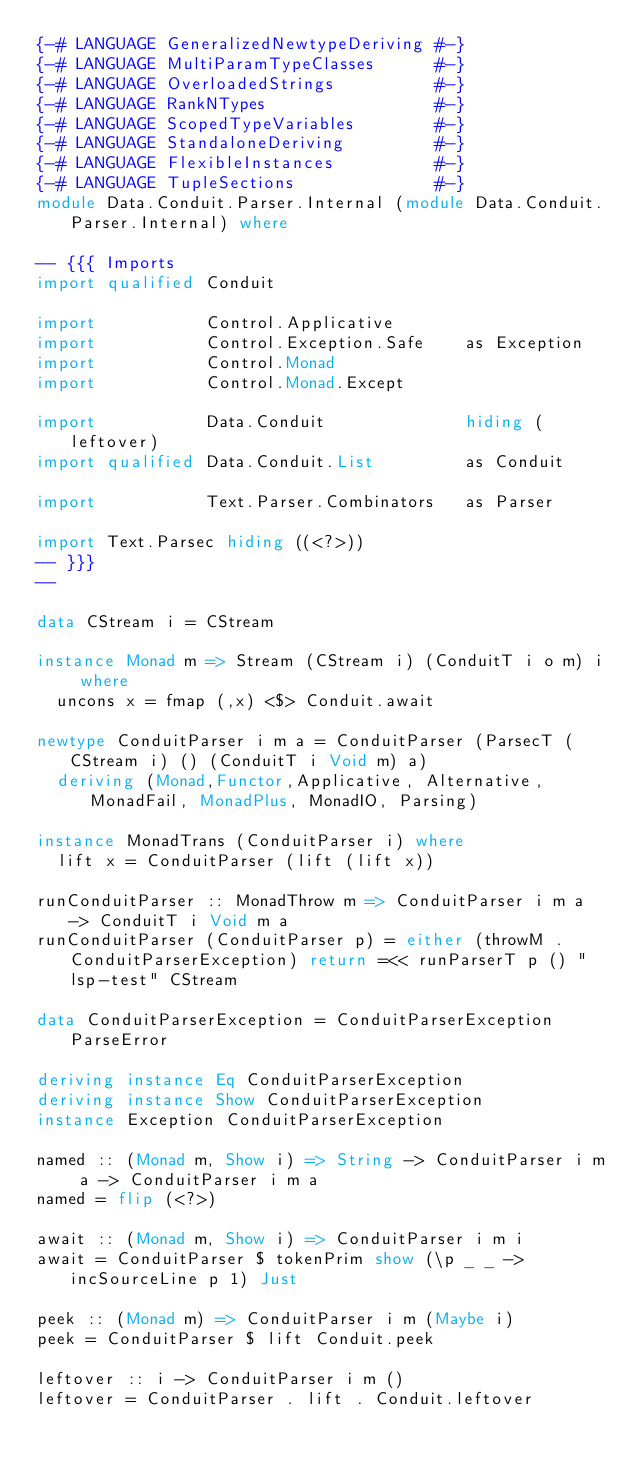<code> <loc_0><loc_0><loc_500><loc_500><_Haskell_>{-# LANGUAGE GeneralizedNewtypeDeriving #-}
{-# LANGUAGE MultiParamTypeClasses      #-}
{-# LANGUAGE OverloadedStrings          #-}
{-# LANGUAGE RankNTypes                 #-}
{-# LANGUAGE ScopedTypeVariables        #-}
{-# LANGUAGE StandaloneDeriving         #-}
{-# LANGUAGE FlexibleInstances          #-}
{-# LANGUAGE TupleSections              #-}
module Data.Conduit.Parser.Internal (module Data.Conduit.Parser.Internal) where

-- {{{ Imports
import qualified Conduit

import           Control.Applicative
import           Control.Exception.Safe    as Exception
import           Control.Monad
import           Control.Monad.Except

import           Data.Conduit              hiding (leftover)
import qualified Data.Conduit.List         as Conduit

import           Text.Parser.Combinators   as Parser

import Text.Parsec hiding ((<?>))
-- }}}
--

data CStream i = CStream

instance Monad m => Stream (CStream i) (ConduitT i o m) i where
  uncons x = fmap (,x) <$> Conduit.await

newtype ConduitParser i m a = ConduitParser (ParsecT (CStream i) () (ConduitT i Void m) a)
  deriving (Monad,Functor,Applicative, Alternative,MonadFail, MonadPlus, MonadIO, Parsing)

instance MonadTrans (ConduitParser i) where
  lift x = ConduitParser (lift (lift x))

runConduitParser :: MonadThrow m => ConduitParser i m a -> ConduitT i Void m a
runConduitParser (ConduitParser p) = either (throwM . ConduitParserException) return =<< runParserT p () "lsp-test" CStream

data ConduitParserException = ConduitParserException ParseError

deriving instance Eq ConduitParserException
deriving instance Show ConduitParserException
instance Exception ConduitParserException

named :: (Monad m, Show i) => String -> ConduitParser i m a -> ConduitParser i m a
named = flip (<?>)

await :: (Monad m, Show i) => ConduitParser i m i
await = ConduitParser $ tokenPrim show (\p _ _ -> incSourceLine p 1) Just

peek :: (Monad m) => ConduitParser i m (Maybe i)
peek = ConduitParser $ lift Conduit.peek

leftover :: i -> ConduitParser i m ()
leftover = ConduitParser . lift . Conduit.leftover
</code> 